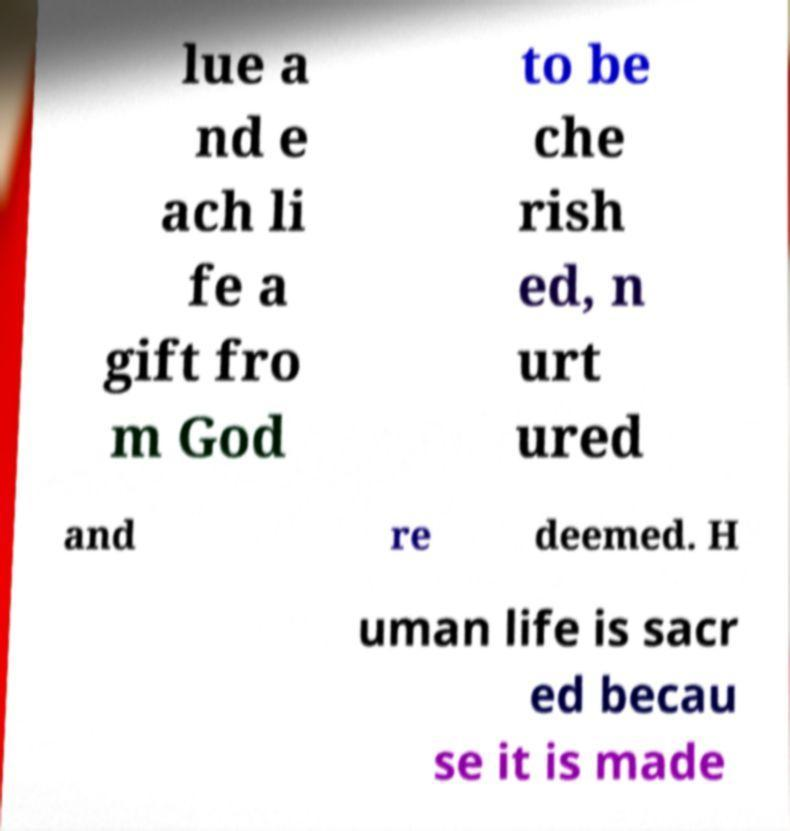Could you assist in decoding the text presented in this image and type it out clearly? lue a nd e ach li fe a gift fro m God to be che rish ed, n urt ured and re deemed. H uman life is sacr ed becau se it is made 